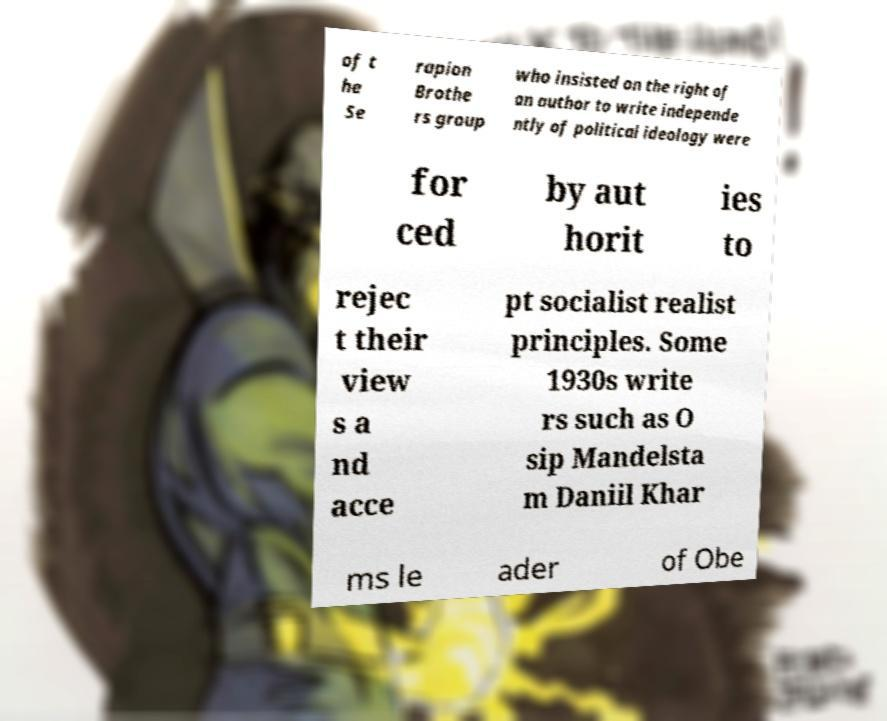Could you extract and type out the text from this image? of t he Se rapion Brothe rs group who insisted on the right of an author to write independe ntly of political ideology were for ced by aut horit ies to rejec t their view s a nd acce pt socialist realist principles. Some 1930s write rs such as O sip Mandelsta m Daniil Khar ms le ader of Obe 